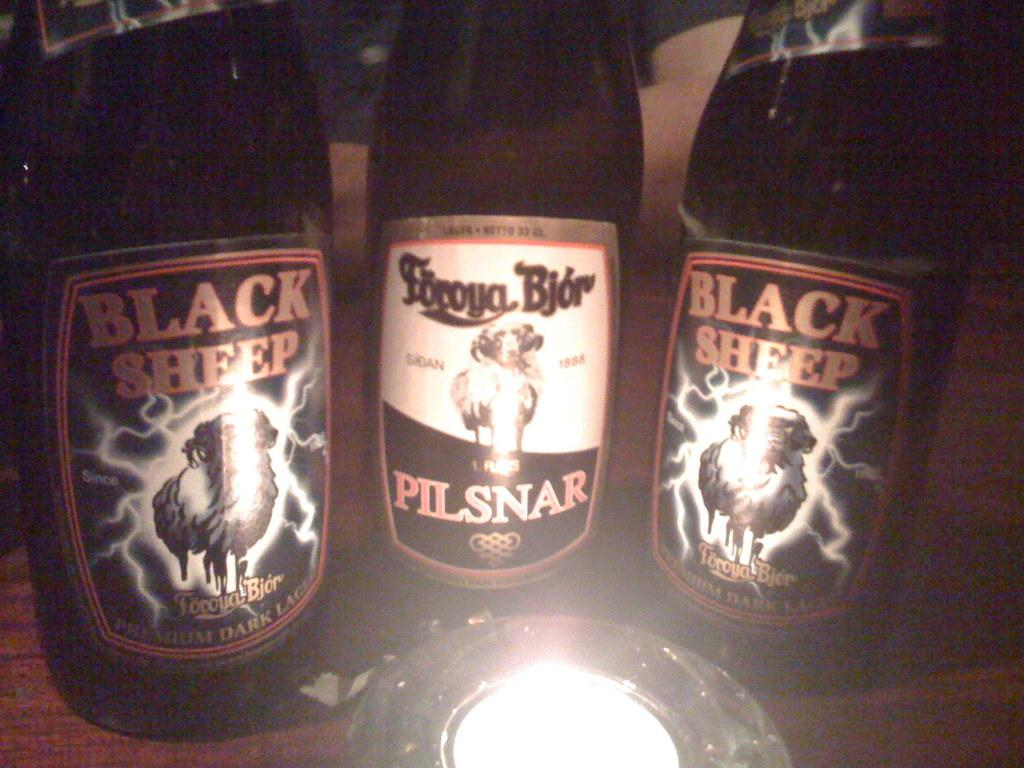<image>
Create a compact narrative representing the image presented. Two bottles of Black Sheep sit on either side of a bottle of pilsnar. 